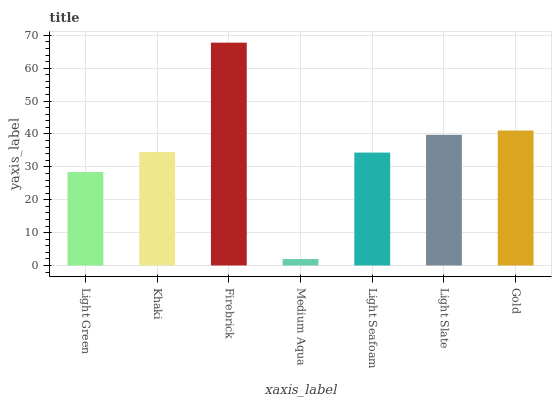Is Khaki the minimum?
Answer yes or no. No. Is Khaki the maximum?
Answer yes or no. No. Is Khaki greater than Light Green?
Answer yes or no. Yes. Is Light Green less than Khaki?
Answer yes or no. Yes. Is Light Green greater than Khaki?
Answer yes or no. No. Is Khaki less than Light Green?
Answer yes or no. No. Is Khaki the high median?
Answer yes or no. Yes. Is Khaki the low median?
Answer yes or no. Yes. Is Light Seafoam the high median?
Answer yes or no. No. Is Medium Aqua the low median?
Answer yes or no. No. 